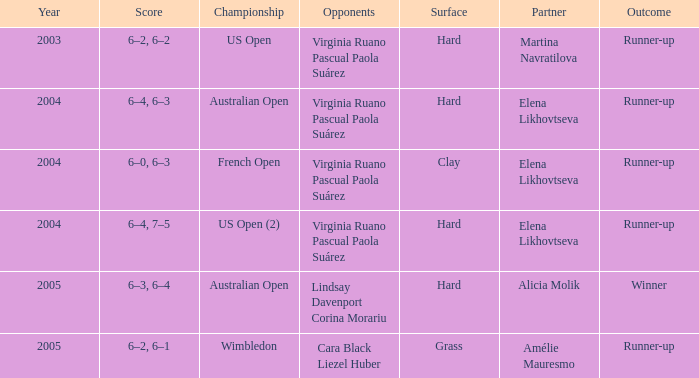When alicia molik is the partner what is the outcome? Winner. 